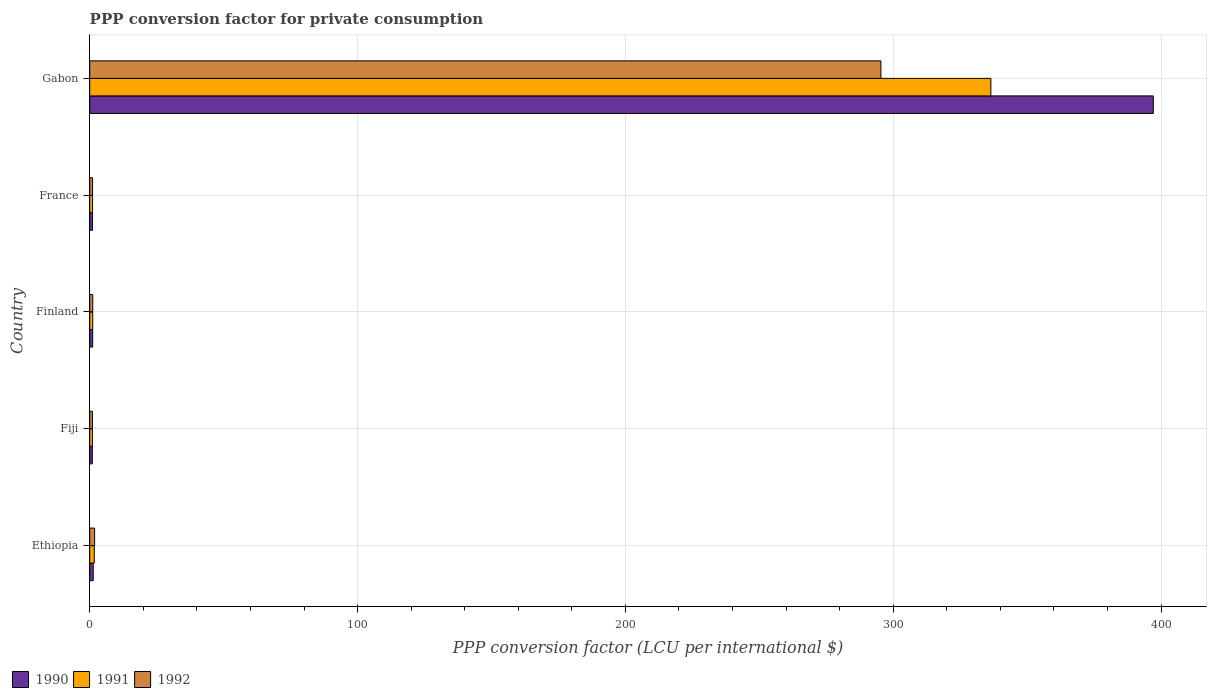How many different coloured bars are there?
Offer a very short reply. 3. How many groups of bars are there?
Give a very brief answer. 5. Are the number of bars on each tick of the Y-axis equal?
Offer a terse response. Yes. What is the PPP conversion factor for private consumption in 1992 in Ethiopia?
Keep it short and to the point. 1.82. Across all countries, what is the maximum PPP conversion factor for private consumption in 1992?
Your response must be concise. 295.39. Across all countries, what is the minimum PPP conversion factor for private consumption in 1992?
Your answer should be very brief. 1.01. In which country was the PPP conversion factor for private consumption in 1991 maximum?
Provide a succinct answer. Gabon. In which country was the PPP conversion factor for private consumption in 1992 minimum?
Your answer should be compact. Fiji. What is the total PPP conversion factor for private consumption in 1991 in the graph?
Your answer should be compact. 341.3. What is the difference between the PPP conversion factor for private consumption in 1990 in France and that in Gabon?
Ensure brevity in your answer.  -396.04. What is the difference between the PPP conversion factor for private consumption in 1990 in France and the PPP conversion factor for private consumption in 1992 in Finland?
Make the answer very short. -0.07. What is the average PPP conversion factor for private consumption in 1990 per country?
Offer a terse response. 80.31. What is the difference between the PPP conversion factor for private consumption in 1991 and PPP conversion factor for private consumption in 1990 in France?
Offer a terse response. -0.01. What is the ratio of the PPP conversion factor for private consumption in 1990 in Fiji to that in Gabon?
Provide a succinct answer. 0. Is the PPP conversion factor for private consumption in 1991 in Fiji less than that in Finland?
Provide a short and direct response. Yes. What is the difference between the highest and the second highest PPP conversion factor for private consumption in 1991?
Provide a short and direct response. 334.75. What is the difference between the highest and the lowest PPP conversion factor for private consumption in 1992?
Give a very brief answer. 294.38. In how many countries, is the PPP conversion factor for private consumption in 1990 greater than the average PPP conversion factor for private consumption in 1990 taken over all countries?
Offer a terse response. 1. Is the sum of the PPP conversion factor for private consumption in 1991 in France and Gabon greater than the maximum PPP conversion factor for private consumption in 1992 across all countries?
Ensure brevity in your answer.  Yes. What does the 1st bar from the bottom in Ethiopia represents?
Your response must be concise. 1990. Is it the case that in every country, the sum of the PPP conversion factor for private consumption in 1990 and PPP conversion factor for private consumption in 1991 is greater than the PPP conversion factor for private consumption in 1992?
Offer a terse response. Yes. How many bars are there?
Make the answer very short. 15. How many countries are there in the graph?
Your answer should be very brief. 5. Are the values on the major ticks of X-axis written in scientific E-notation?
Offer a terse response. No. Does the graph contain grids?
Offer a very short reply. Yes. How are the legend labels stacked?
Offer a terse response. Horizontal. What is the title of the graph?
Provide a short and direct response. PPP conversion factor for private consumption. What is the label or title of the X-axis?
Ensure brevity in your answer.  PPP conversion factor (LCU per international $). What is the label or title of the Y-axis?
Keep it short and to the point. Country. What is the PPP conversion factor (LCU per international $) in 1990 in Ethiopia?
Ensure brevity in your answer.  1.3. What is the PPP conversion factor (LCU per international $) of 1991 in Ethiopia?
Make the answer very short. 1.7. What is the PPP conversion factor (LCU per international $) in 1992 in Ethiopia?
Ensure brevity in your answer.  1.82. What is the PPP conversion factor (LCU per international $) in 1990 in Fiji?
Keep it short and to the point. 0.97. What is the PPP conversion factor (LCU per international $) of 1991 in Fiji?
Your answer should be very brief. 1. What is the PPP conversion factor (LCU per international $) in 1992 in Fiji?
Your answer should be compact. 1.01. What is the PPP conversion factor (LCU per international $) in 1990 in Finland?
Provide a short and direct response. 1.1. What is the PPP conversion factor (LCU per international $) of 1991 in Finland?
Provide a short and direct response. 1.12. What is the PPP conversion factor (LCU per international $) of 1992 in Finland?
Provide a short and direct response. 1.13. What is the PPP conversion factor (LCU per international $) in 1990 in France?
Provide a short and direct response. 1.06. What is the PPP conversion factor (LCU per international $) of 1991 in France?
Offer a very short reply. 1.05. What is the PPP conversion factor (LCU per international $) of 1992 in France?
Your answer should be very brief. 1.05. What is the PPP conversion factor (LCU per international $) of 1990 in Gabon?
Your answer should be compact. 397.1. What is the PPP conversion factor (LCU per international $) of 1991 in Gabon?
Make the answer very short. 336.44. What is the PPP conversion factor (LCU per international $) in 1992 in Gabon?
Provide a succinct answer. 295.39. Across all countries, what is the maximum PPP conversion factor (LCU per international $) in 1990?
Your answer should be very brief. 397.1. Across all countries, what is the maximum PPP conversion factor (LCU per international $) of 1991?
Offer a very short reply. 336.44. Across all countries, what is the maximum PPP conversion factor (LCU per international $) in 1992?
Your answer should be very brief. 295.39. Across all countries, what is the minimum PPP conversion factor (LCU per international $) in 1990?
Your answer should be compact. 0.97. Across all countries, what is the minimum PPP conversion factor (LCU per international $) in 1991?
Provide a succinct answer. 1. Across all countries, what is the minimum PPP conversion factor (LCU per international $) of 1992?
Make the answer very short. 1.01. What is the total PPP conversion factor (LCU per international $) of 1990 in the graph?
Offer a very short reply. 401.53. What is the total PPP conversion factor (LCU per international $) of 1991 in the graph?
Your answer should be compact. 341.3. What is the total PPP conversion factor (LCU per international $) of 1992 in the graph?
Ensure brevity in your answer.  300.4. What is the difference between the PPP conversion factor (LCU per international $) in 1990 in Ethiopia and that in Fiji?
Your answer should be compact. 0.33. What is the difference between the PPP conversion factor (LCU per international $) in 1991 in Ethiopia and that in Fiji?
Your answer should be compact. 0.7. What is the difference between the PPP conversion factor (LCU per international $) in 1992 in Ethiopia and that in Fiji?
Ensure brevity in your answer.  0.81. What is the difference between the PPP conversion factor (LCU per international $) in 1990 in Ethiopia and that in Finland?
Ensure brevity in your answer.  0.2. What is the difference between the PPP conversion factor (LCU per international $) in 1991 in Ethiopia and that in Finland?
Provide a short and direct response. 0.58. What is the difference between the PPP conversion factor (LCU per international $) in 1992 in Ethiopia and that in Finland?
Offer a very short reply. 0.69. What is the difference between the PPP conversion factor (LCU per international $) of 1990 in Ethiopia and that in France?
Keep it short and to the point. 0.25. What is the difference between the PPP conversion factor (LCU per international $) in 1991 in Ethiopia and that in France?
Ensure brevity in your answer.  0.65. What is the difference between the PPP conversion factor (LCU per international $) in 1992 in Ethiopia and that in France?
Your answer should be very brief. 0.77. What is the difference between the PPP conversion factor (LCU per international $) of 1990 in Ethiopia and that in Gabon?
Ensure brevity in your answer.  -395.8. What is the difference between the PPP conversion factor (LCU per international $) of 1991 in Ethiopia and that in Gabon?
Give a very brief answer. -334.75. What is the difference between the PPP conversion factor (LCU per international $) of 1992 in Ethiopia and that in Gabon?
Offer a terse response. -293.57. What is the difference between the PPP conversion factor (LCU per international $) in 1990 in Fiji and that in Finland?
Your answer should be compact. -0.13. What is the difference between the PPP conversion factor (LCU per international $) of 1991 in Fiji and that in Finland?
Ensure brevity in your answer.  -0.12. What is the difference between the PPP conversion factor (LCU per international $) in 1992 in Fiji and that in Finland?
Your response must be concise. -0.11. What is the difference between the PPP conversion factor (LCU per international $) in 1990 in Fiji and that in France?
Your answer should be compact. -0.08. What is the difference between the PPP conversion factor (LCU per international $) of 1991 in Fiji and that in France?
Your answer should be compact. -0.05. What is the difference between the PPP conversion factor (LCU per international $) in 1992 in Fiji and that in France?
Make the answer very short. -0.04. What is the difference between the PPP conversion factor (LCU per international $) of 1990 in Fiji and that in Gabon?
Ensure brevity in your answer.  -396.12. What is the difference between the PPP conversion factor (LCU per international $) in 1991 in Fiji and that in Gabon?
Your response must be concise. -335.45. What is the difference between the PPP conversion factor (LCU per international $) of 1992 in Fiji and that in Gabon?
Make the answer very short. -294.38. What is the difference between the PPP conversion factor (LCU per international $) in 1990 in Finland and that in France?
Give a very brief answer. 0.05. What is the difference between the PPP conversion factor (LCU per international $) of 1991 in Finland and that in France?
Keep it short and to the point. 0.07. What is the difference between the PPP conversion factor (LCU per international $) in 1992 in Finland and that in France?
Offer a very short reply. 0.08. What is the difference between the PPP conversion factor (LCU per international $) in 1990 in Finland and that in Gabon?
Ensure brevity in your answer.  -396. What is the difference between the PPP conversion factor (LCU per international $) of 1991 in Finland and that in Gabon?
Your answer should be compact. -335.33. What is the difference between the PPP conversion factor (LCU per international $) of 1992 in Finland and that in Gabon?
Your answer should be very brief. -294.26. What is the difference between the PPP conversion factor (LCU per international $) of 1990 in France and that in Gabon?
Provide a short and direct response. -396.04. What is the difference between the PPP conversion factor (LCU per international $) of 1991 in France and that in Gabon?
Offer a very short reply. -335.39. What is the difference between the PPP conversion factor (LCU per international $) in 1992 in France and that in Gabon?
Offer a terse response. -294.34. What is the difference between the PPP conversion factor (LCU per international $) of 1990 in Ethiopia and the PPP conversion factor (LCU per international $) of 1991 in Fiji?
Keep it short and to the point. 0.31. What is the difference between the PPP conversion factor (LCU per international $) in 1990 in Ethiopia and the PPP conversion factor (LCU per international $) in 1992 in Fiji?
Your answer should be compact. 0.29. What is the difference between the PPP conversion factor (LCU per international $) of 1991 in Ethiopia and the PPP conversion factor (LCU per international $) of 1992 in Fiji?
Provide a succinct answer. 0.68. What is the difference between the PPP conversion factor (LCU per international $) of 1990 in Ethiopia and the PPP conversion factor (LCU per international $) of 1991 in Finland?
Make the answer very short. 0.19. What is the difference between the PPP conversion factor (LCU per international $) of 1990 in Ethiopia and the PPP conversion factor (LCU per international $) of 1992 in Finland?
Your answer should be compact. 0.18. What is the difference between the PPP conversion factor (LCU per international $) of 1991 in Ethiopia and the PPP conversion factor (LCU per international $) of 1992 in Finland?
Ensure brevity in your answer.  0.57. What is the difference between the PPP conversion factor (LCU per international $) in 1990 in Ethiopia and the PPP conversion factor (LCU per international $) in 1991 in France?
Your response must be concise. 0.25. What is the difference between the PPP conversion factor (LCU per international $) in 1990 in Ethiopia and the PPP conversion factor (LCU per international $) in 1992 in France?
Offer a terse response. 0.25. What is the difference between the PPP conversion factor (LCU per international $) of 1991 in Ethiopia and the PPP conversion factor (LCU per international $) of 1992 in France?
Make the answer very short. 0.65. What is the difference between the PPP conversion factor (LCU per international $) in 1990 in Ethiopia and the PPP conversion factor (LCU per international $) in 1991 in Gabon?
Offer a very short reply. -335.14. What is the difference between the PPP conversion factor (LCU per international $) in 1990 in Ethiopia and the PPP conversion factor (LCU per international $) in 1992 in Gabon?
Provide a short and direct response. -294.09. What is the difference between the PPP conversion factor (LCU per international $) in 1991 in Ethiopia and the PPP conversion factor (LCU per international $) in 1992 in Gabon?
Ensure brevity in your answer.  -293.69. What is the difference between the PPP conversion factor (LCU per international $) of 1990 in Fiji and the PPP conversion factor (LCU per international $) of 1991 in Finland?
Your answer should be very brief. -0.14. What is the difference between the PPP conversion factor (LCU per international $) of 1990 in Fiji and the PPP conversion factor (LCU per international $) of 1992 in Finland?
Your answer should be very brief. -0.15. What is the difference between the PPP conversion factor (LCU per international $) in 1991 in Fiji and the PPP conversion factor (LCU per international $) in 1992 in Finland?
Provide a short and direct response. -0.13. What is the difference between the PPP conversion factor (LCU per international $) of 1990 in Fiji and the PPP conversion factor (LCU per international $) of 1991 in France?
Offer a terse response. -0.08. What is the difference between the PPP conversion factor (LCU per international $) of 1990 in Fiji and the PPP conversion factor (LCU per international $) of 1992 in France?
Provide a succinct answer. -0.08. What is the difference between the PPP conversion factor (LCU per international $) in 1991 in Fiji and the PPP conversion factor (LCU per international $) in 1992 in France?
Provide a short and direct response. -0.05. What is the difference between the PPP conversion factor (LCU per international $) of 1990 in Fiji and the PPP conversion factor (LCU per international $) of 1991 in Gabon?
Provide a short and direct response. -335.47. What is the difference between the PPP conversion factor (LCU per international $) in 1990 in Fiji and the PPP conversion factor (LCU per international $) in 1992 in Gabon?
Your response must be concise. -294.42. What is the difference between the PPP conversion factor (LCU per international $) in 1991 in Fiji and the PPP conversion factor (LCU per international $) in 1992 in Gabon?
Make the answer very short. -294.4. What is the difference between the PPP conversion factor (LCU per international $) in 1990 in Finland and the PPP conversion factor (LCU per international $) in 1991 in France?
Provide a short and direct response. 0.05. What is the difference between the PPP conversion factor (LCU per international $) of 1990 in Finland and the PPP conversion factor (LCU per international $) of 1992 in France?
Your answer should be compact. 0.05. What is the difference between the PPP conversion factor (LCU per international $) in 1991 in Finland and the PPP conversion factor (LCU per international $) in 1992 in France?
Give a very brief answer. 0.07. What is the difference between the PPP conversion factor (LCU per international $) of 1990 in Finland and the PPP conversion factor (LCU per international $) of 1991 in Gabon?
Provide a short and direct response. -335.34. What is the difference between the PPP conversion factor (LCU per international $) of 1990 in Finland and the PPP conversion factor (LCU per international $) of 1992 in Gabon?
Your answer should be very brief. -294.29. What is the difference between the PPP conversion factor (LCU per international $) in 1991 in Finland and the PPP conversion factor (LCU per international $) in 1992 in Gabon?
Your answer should be compact. -294.27. What is the difference between the PPP conversion factor (LCU per international $) in 1990 in France and the PPP conversion factor (LCU per international $) in 1991 in Gabon?
Your answer should be very brief. -335.39. What is the difference between the PPP conversion factor (LCU per international $) in 1990 in France and the PPP conversion factor (LCU per international $) in 1992 in Gabon?
Keep it short and to the point. -294.33. What is the difference between the PPP conversion factor (LCU per international $) of 1991 in France and the PPP conversion factor (LCU per international $) of 1992 in Gabon?
Your answer should be compact. -294.34. What is the average PPP conversion factor (LCU per international $) of 1990 per country?
Your answer should be compact. 80.31. What is the average PPP conversion factor (LCU per international $) of 1991 per country?
Your answer should be compact. 68.26. What is the average PPP conversion factor (LCU per international $) of 1992 per country?
Make the answer very short. 60.08. What is the difference between the PPP conversion factor (LCU per international $) in 1990 and PPP conversion factor (LCU per international $) in 1991 in Ethiopia?
Make the answer very short. -0.39. What is the difference between the PPP conversion factor (LCU per international $) of 1990 and PPP conversion factor (LCU per international $) of 1992 in Ethiopia?
Your response must be concise. -0.52. What is the difference between the PPP conversion factor (LCU per international $) of 1991 and PPP conversion factor (LCU per international $) of 1992 in Ethiopia?
Give a very brief answer. -0.12. What is the difference between the PPP conversion factor (LCU per international $) in 1990 and PPP conversion factor (LCU per international $) in 1991 in Fiji?
Ensure brevity in your answer.  -0.02. What is the difference between the PPP conversion factor (LCU per international $) in 1990 and PPP conversion factor (LCU per international $) in 1992 in Fiji?
Give a very brief answer. -0.04. What is the difference between the PPP conversion factor (LCU per international $) in 1991 and PPP conversion factor (LCU per international $) in 1992 in Fiji?
Keep it short and to the point. -0.02. What is the difference between the PPP conversion factor (LCU per international $) of 1990 and PPP conversion factor (LCU per international $) of 1991 in Finland?
Offer a very short reply. -0.02. What is the difference between the PPP conversion factor (LCU per international $) in 1990 and PPP conversion factor (LCU per international $) in 1992 in Finland?
Offer a very short reply. -0.03. What is the difference between the PPP conversion factor (LCU per international $) in 1991 and PPP conversion factor (LCU per international $) in 1992 in Finland?
Offer a very short reply. -0.01. What is the difference between the PPP conversion factor (LCU per international $) in 1990 and PPP conversion factor (LCU per international $) in 1991 in France?
Your response must be concise. 0.01. What is the difference between the PPP conversion factor (LCU per international $) in 1990 and PPP conversion factor (LCU per international $) in 1992 in France?
Provide a short and direct response. 0.01. What is the difference between the PPP conversion factor (LCU per international $) in 1991 and PPP conversion factor (LCU per international $) in 1992 in France?
Give a very brief answer. 0. What is the difference between the PPP conversion factor (LCU per international $) in 1990 and PPP conversion factor (LCU per international $) in 1991 in Gabon?
Your answer should be very brief. 60.65. What is the difference between the PPP conversion factor (LCU per international $) of 1990 and PPP conversion factor (LCU per international $) of 1992 in Gabon?
Keep it short and to the point. 101.71. What is the difference between the PPP conversion factor (LCU per international $) in 1991 and PPP conversion factor (LCU per international $) in 1992 in Gabon?
Offer a very short reply. 41.05. What is the ratio of the PPP conversion factor (LCU per international $) of 1990 in Ethiopia to that in Fiji?
Provide a succinct answer. 1.34. What is the ratio of the PPP conversion factor (LCU per international $) of 1991 in Ethiopia to that in Fiji?
Keep it short and to the point. 1.7. What is the ratio of the PPP conversion factor (LCU per international $) of 1992 in Ethiopia to that in Fiji?
Give a very brief answer. 1.8. What is the ratio of the PPP conversion factor (LCU per international $) in 1990 in Ethiopia to that in Finland?
Offer a very short reply. 1.18. What is the ratio of the PPP conversion factor (LCU per international $) of 1991 in Ethiopia to that in Finland?
Provide a succinct answer. 1.52. What is the ratio of the PPP conversion factor (LCU per international $) of 1992 in Ethiopia to that in Finland?
Provide a succinct answer. 1.62. What is the ratio of the PPP conversion factor (LCU per international $) in 1990 in Ethiopia to that in France?
Keep it short and to the point. 1.23. What is the ratio of the PPP conversion factor (LCU per international $) in 1991 in Ethiopia to that in France?
Keep it short and to the point. 1.62. What is the ratio of the PPP conversion factor (LCU per international $) in 1992 in Ethiopia to that in France?
Ensure brevity in your answer.  1.73. What is the ratio of the PPP conversion factor (LCU per international $) in 1990 in Ethiopia to that in Gabon?
Give a very brief answer. 0. What is the ratio of the PPP conversion factor (LCU per international $) in 1991 in Ethiopia to that in Gabon?
Give a very brief answer. 0.01. What is the ratio of the PPP conversion factor (LCU per international $) of 1992 in Ethiopia to that in Gabon?
Your answer should be very brief. 0.01. What is the ratio of the PPP conversion factor (LCU per international $) of 1990 in Fiji to that in Finland?
Give a very brief answer. 0.88. What is the ratio of the PPP conversion factor (LCU per international $) in 1991 in Fiji to that in Finland?
Give a very brief answer. 0.89. What is the ratio of the PPP conversion factor (LCU per international $) in 1992 in Fiji to that in Finland?
Offer a terse response. 0.9. What is the ratio of the PPP conversion factor (LCU per international $) in 1990 in Fiji to that in France?
Your answer should be very brief. 0.92. What is the ratio of the PPP conversion factor (LCU per international $) in 1991 in Fiji to that in France?
Your response must be concise. 0.95. What is the ratio of the PPP conversion factor (LCU per international $) of 1992 in Fiji to that in France?
Your response must be concise. 0.97. What is the ratio of the PPP conversion factor (LCU per international $) in 1990 in Fiji to that in Gabon?
Give a very brief answer. 0. What is the ratio of the PPP conversion factor (LCU per international $) of 1991 in Fiji to that in Gabon?
Offer a very short reply. 0. What is the ratio of the PPP conversion factor (LCU per international $) of 1992 in Fiji to that in Gabon?
Keep it short and to the point. 0. What is the ratio of the PPP conversion factor (LCU per international $) of 1990 in Finland to that in France?
Your answer should be very brief. 1.04. What is the ratio of the PPP conversion factor (LCU per international $) in 1991 in Finland to that in France?
Provide a short and direct response. 1.06. What is the ratio of the PPP conversion factor (LCU per international $) of 1992 in Finland to that in France?
Provide a short and direct response. 1.07. What is the ratio of the PPP conversion factor (LCU per international $) in 1990 in Finland to that in Gabon?
Provide a short and direct response. 0. What is the ratio of the PPP conversion factor (LCU per international $) in 1991 in Finland to that in Gabon?
Give a very brief answer. 0. What is the ratio of the PPP conversion factor (LCU per international $) in 1992 in Finland to that in Gabon?
Make the answer very short. 0. What is the ratio of the PPP conversion factor (LCU per international $) in 1990 in France to that in Gabon?
Provide a short and direct response. 0. What is the ratio of the PPP conversion factor (LCU per international $) of 1991 in France to that in Gabon?
Your answer should be very brief. 0. What is the ratio of the PPP conversion factor (LCU per international $) in 1992 in France to that in Gabon?
Your response must be concise. 0. What is the difference between the highest and the second highest PPP conversion factor (LCU per international $) of 1990?
Ensure brevity in your answer.  395.8. What is the difference between the highest and the second highest PPP conversion factor (LCU per international $) of 1991?
Ensure brevity in your answer.  334.75. What is the difference between the highest and the second highest PPP conversion factor (LCU per international $) in 1992?
Keep it short and to the point. 293.57. What is the difference between the highest and the lowest PPP conversion factor (LCU per international $) in 1990?
Give a very brief answer. 396.12. What is the difference between the highest and the lowest PPP conversion factor (LCU per international $) of 1991?
Provide a short and direct response. 335.45. What is the difference between the highest and the lowest PPP conversion factor (LCU per international $) in 1992?
Make the answer very short. 294.38. 